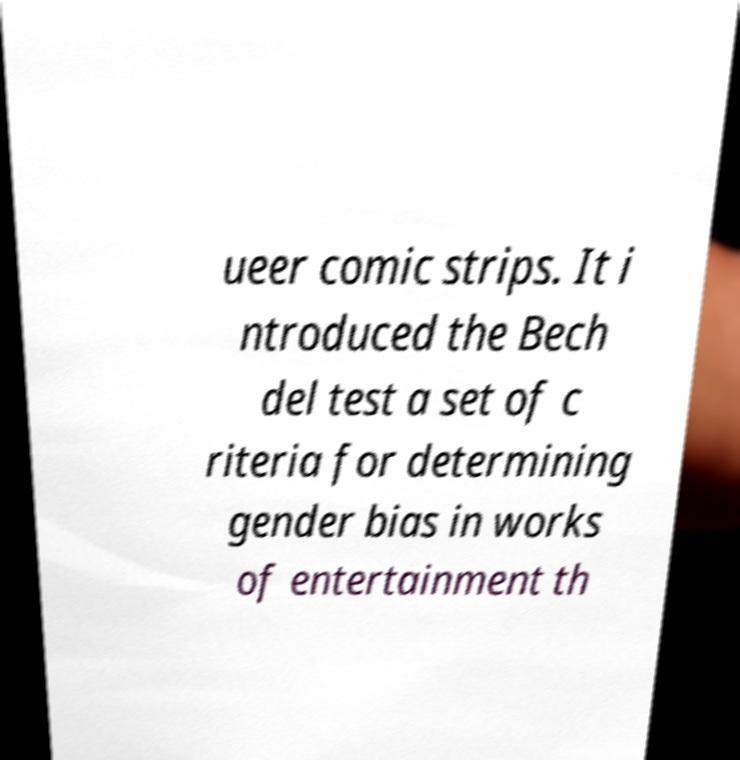What messages or text are displayed in this image? I need them in a readable, typed format. ueer comic strips. It i ntroduced the Bech del test a set of c riteria for determining gender bias in works of entertainment th 